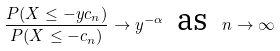Convert formula to latex. <formula><loc_0><loc_0><loc_500><loc_500>\frac { P ( X \leq - y c _ { n } ) } { P ( X \leq - c _ { n } ) } \rightarrow y ^ { - \alpha } \text { \ as \ } n \rightarrow \infty</formula> 